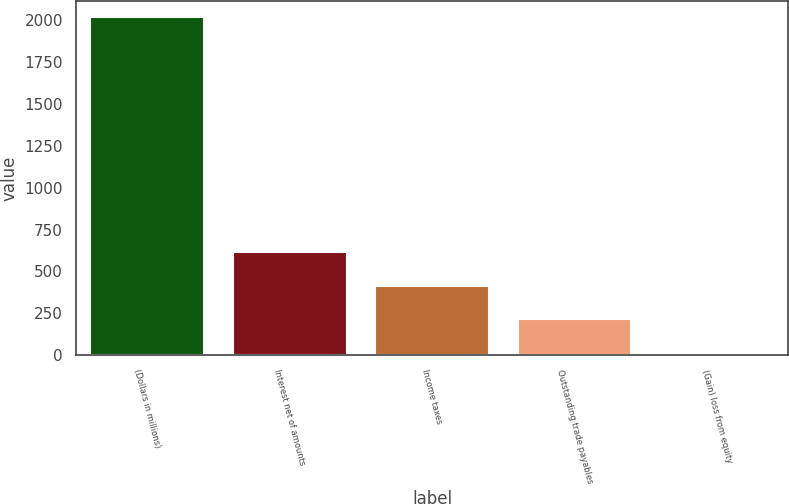Convert chart. <chart><loc_0><loc_0><loc_500><loc_500><bar_chart><fcel>(Dollars in millions)<fcel>Interest net of amounts<fcel>Income taxes<fcel>Outstanding trade payables<fcel>(Gain) loss from equity<nl><fcel>2017<fcel>614.9<fcel>414.6<fcel>214.3<fcel>14<nl></chart> 